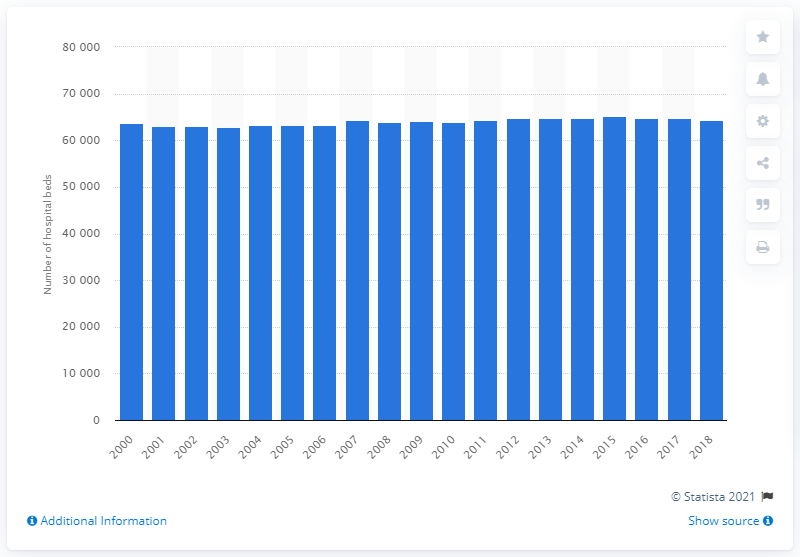Outline some significant characteristics in this image. In 2000, there were 64,285 hospital beds available in Austria. In the year 2019, there were 64,285 hospitals in Austria. 